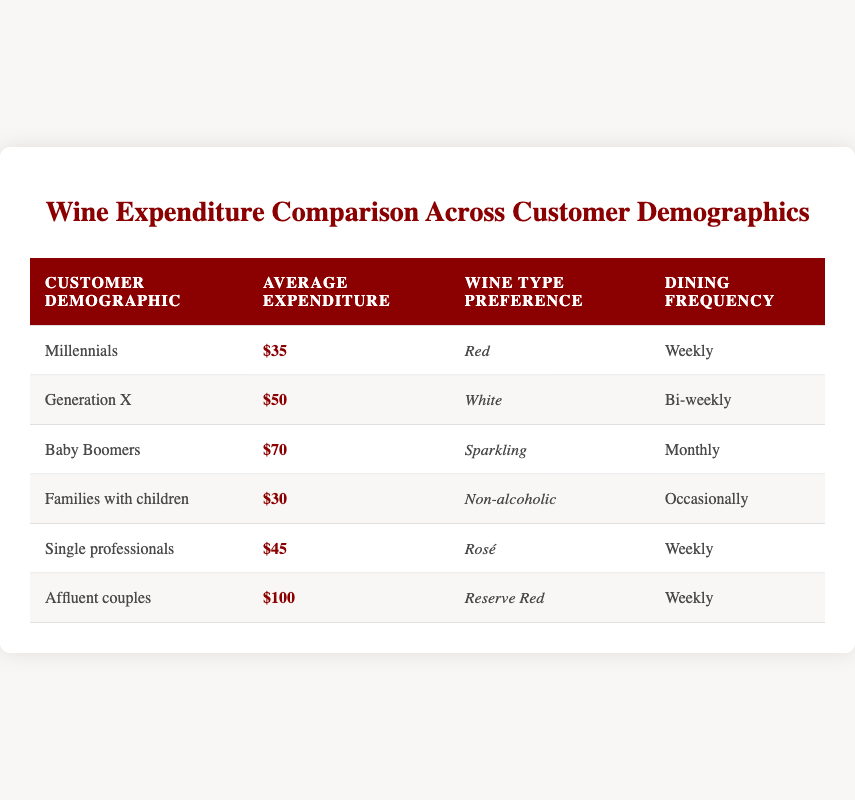What is the average wine expenditure for Millennials? The table indicates that Millennials have an average expenditure of $35. This information is directly accessible from the “Average Expenditure” column for the row corresponding to Millennials.
Answer: 35 Which demographic has the highest average wine expenditure? By reviewing the “Average Expenditure” column, it is clear that Affluent couples spend the most at $100. This is the maximum value in that column.
Answer: Affluent couples What type of wine do Baby Boomers prefer? According to the table, Baby Boomers prefer Sparkling wine, as listed in the “Wine Type Preference” column for their demographic row.
Answer: Sparkling How much more do Baby Boomers spend on wine compared to Families with children? Baby Boomers have an average expenditure of $70, while Families with children spend $30. The difference is calculated as 70 - 30 = 40. Therefore, Baby Boomers spend $40 more on average.
Answer: 40 Do single professionals dine weekly? The table shows that single professionals have a dining frequency listed as "Weekly," which confirms that they do dine out weekly.
Answer: Yes Which demographic prefers Red wine, and what is their expenditure? Looking at the table, Millennials prefer Red wine, and they have an average expenditure of $35. The preference and expenditure are listed in the respective columns for Millennials.
Answer: Millennials, 35 How many customer demographics spend less than $50 on wine? By filtering the average expenditures in the table, we see that both Millennials ($35), Families with children ($30), and Single professionals ($45) spend less than $50. Counting these gives us a total of three demographics.
Answer: 3 Calculate the average wine expenditure for all customer demographics listed in the table. To find the average, sum all the average expenditures: 35 + 50 + 70 + 30 + 45 + 100 = 330. There are six demographics, so the average is 330 ÷ 6 = 55.
Answer: 55 How often do Families with children dine out? The table records that Families with children dine out “Occasionally” which reveals their dining frequency.
Answer: Occasionally 